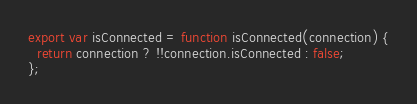<code> <loc_0><loc_0><loc_500><loc_500><_JavaScript_>export var isConnected = function isConnected(connection) {
  return connection ? !!connection.isConnected : false;
};</code> 